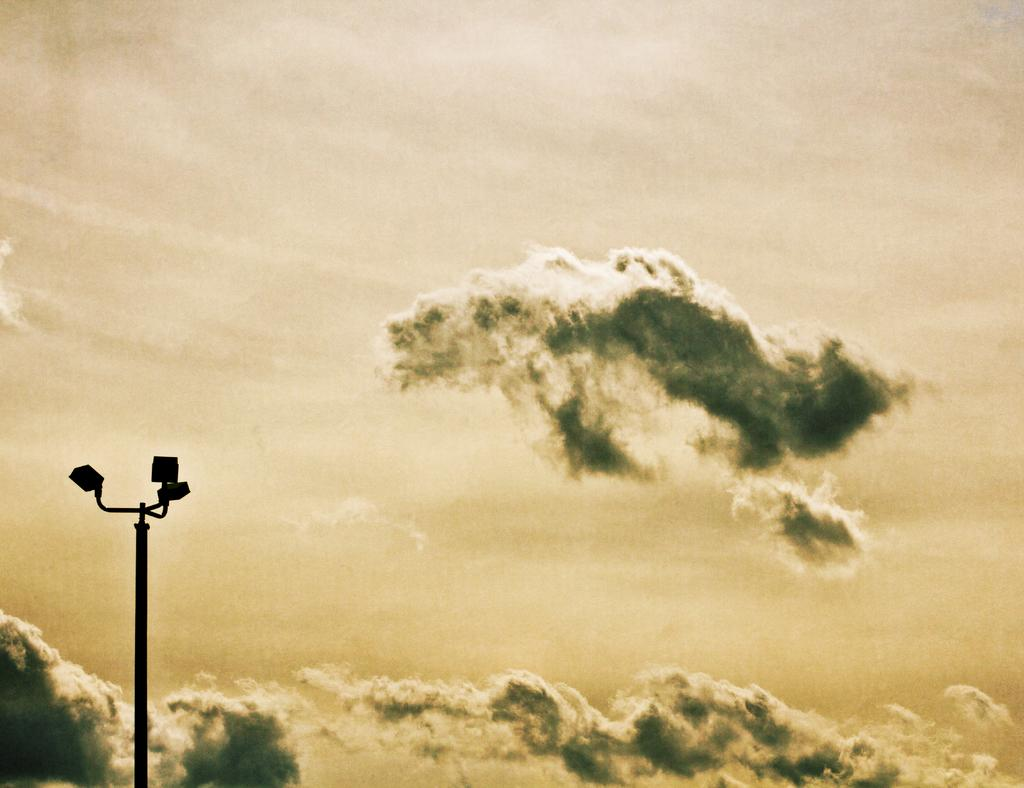What type of lighting is present on the pole in the image? There are street lights on a pole in the image. What is the condition of the sky in the image? The sky is cloudy in the image. What type of instrument is the crook playing in the image? There is no crook or instrument present in the image; it only features street lights and a cloudy sky. 